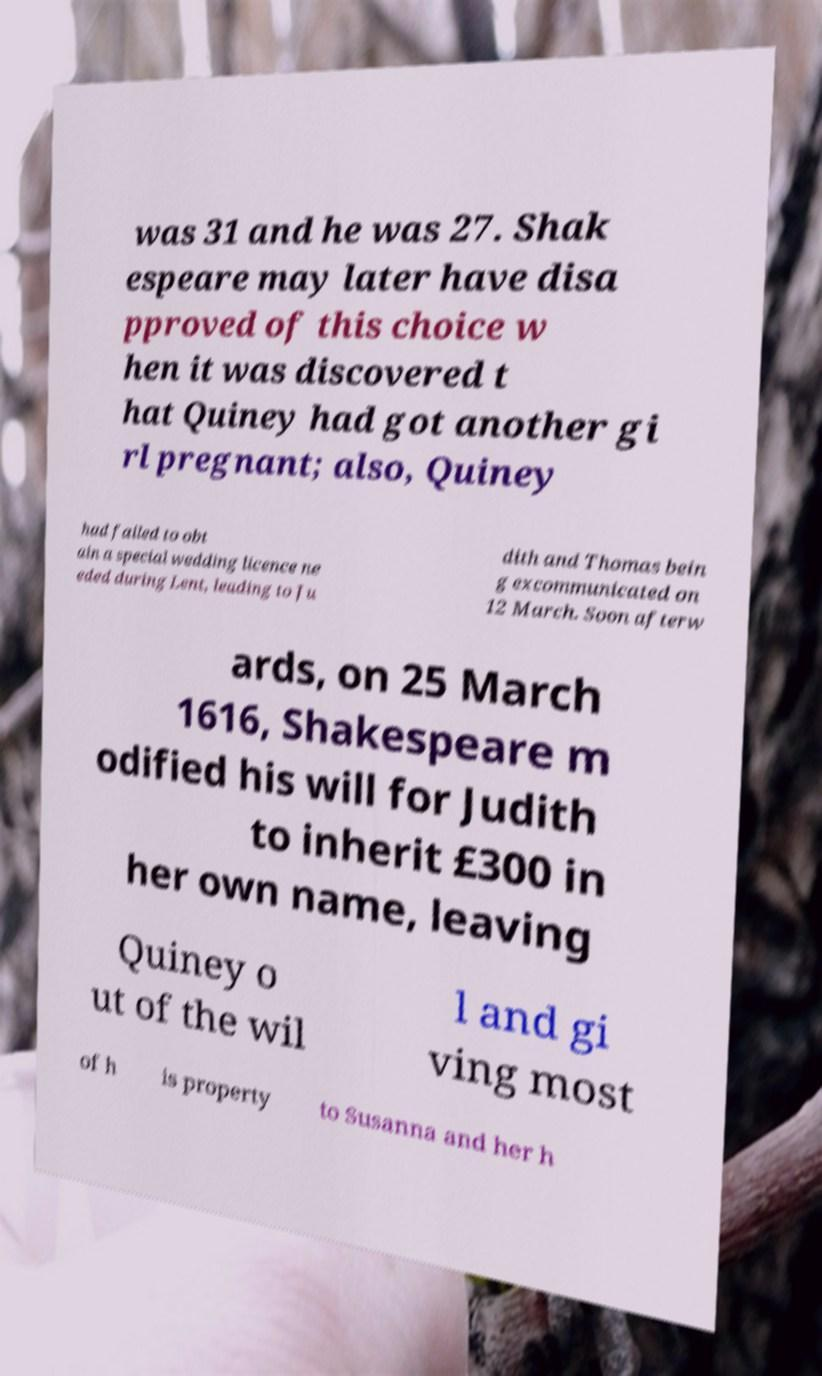Could you extract and type out the text from this image? was 31 and he was 27. Shak espeare may later have disa pproved of this choice w hen it was discovered t hat Quiney had got another gi rl pregnant; also, Quiney had failed to obt ain a special wedding licence ne eded during Lent, leading to Ju dith and Thomas bein g excommunicated on 12 March. Soon afterw ards, on 25 March 1616, Shakespeare m odified his will for Judith to inherit £300 in her own name, leaving Quiney o ut of the wil l and gi ving most of h is property to Susanna and her h 